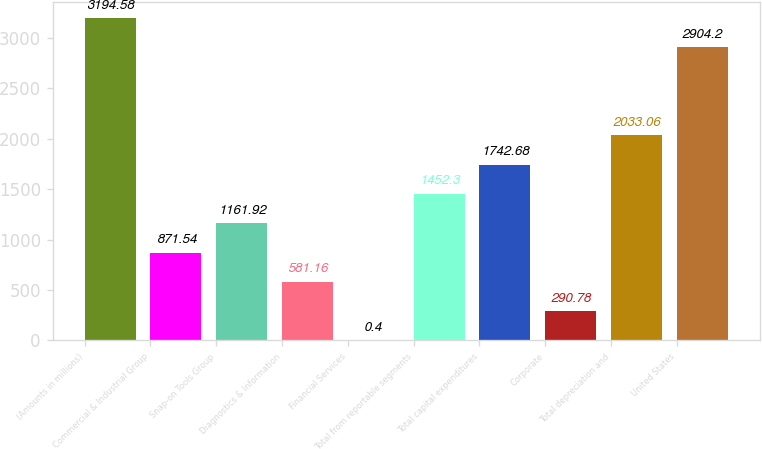Convert chart. <chart><loc_0><loc_0><loc_500><loc_500><bar_chart><fcel>(Amounts in millions)<fcel>Commercial & Industrial Group<fcel>Snap-on Tools Group<fcel>Diagnostics & Information<fcel>Financial Services<fcel>Total from reportable segments<fcel>Total capital expenditures<fcel>Corporate<fcel>Total depreciation and<fcel>United States<nl><fcel>3194.58<fcel>871.54<fcel>1161.92<fcel>581.16<fcel>0.4<fcel>1452.3<fcel>1742.68<fcel>290.78<fcel>2033.06<fcel>2904.2<nl></chart> 